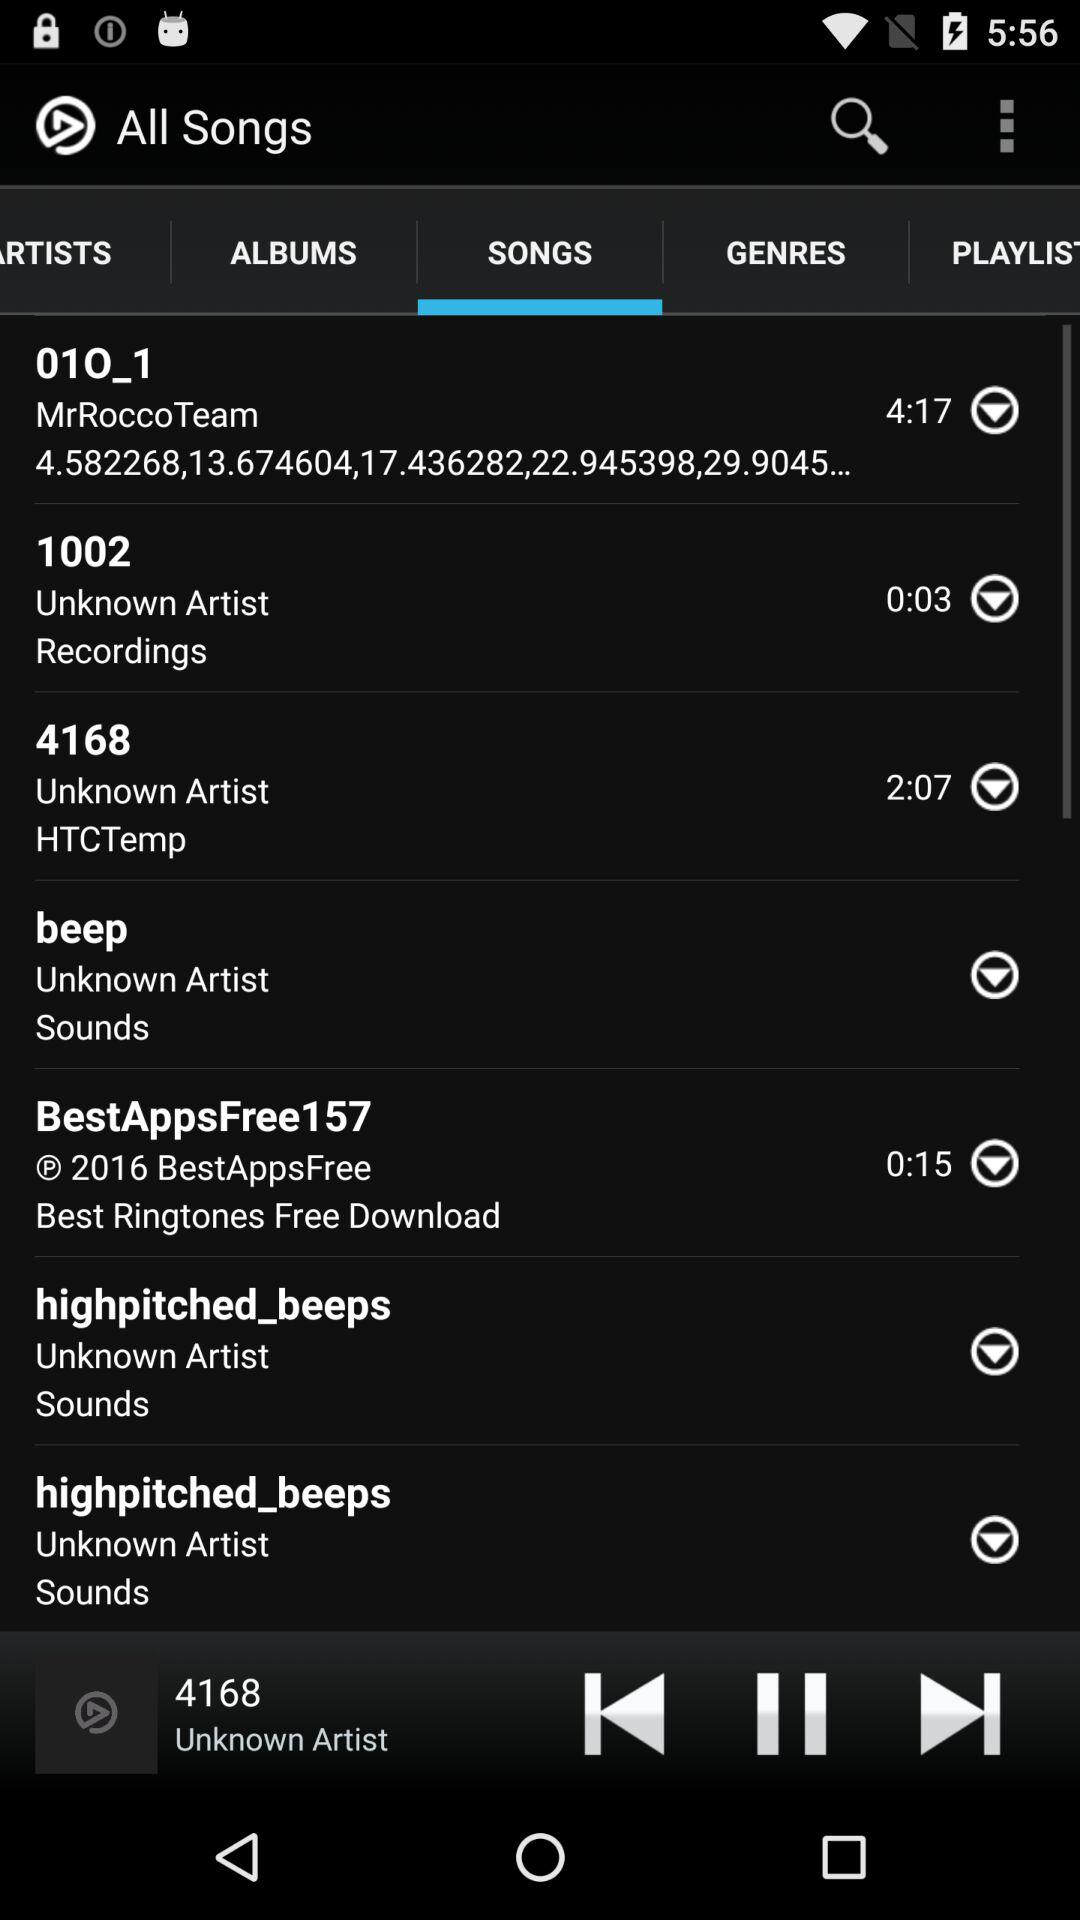What is the duration of "01O_1"? The duration is 4 minutes 17 seconds. 